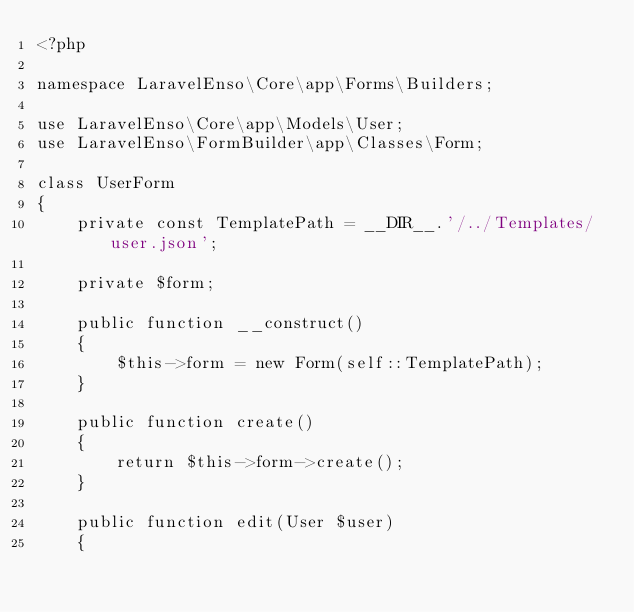Convert code to text. <code><loc_0><loc_0><loc_500><loc_500><_PHP_><?php

namespace LaravelEnso\Core\app\Forms\Builders;

use LaravelEnso\Core\app\Models\User;
use LaravelEnso\FormBuilder\app\Classes\Form;

class UserForm
{
    private const TemplatePath = __DIR__.'/../Templates/user.json';

    private $form;

    public function __construct()
    {
        $this->form = new Form(self::TemplatePath);
    }

    public function create()
    {
        return $this->form->create();
    }

    public function edit(User $user)
    {</code> 